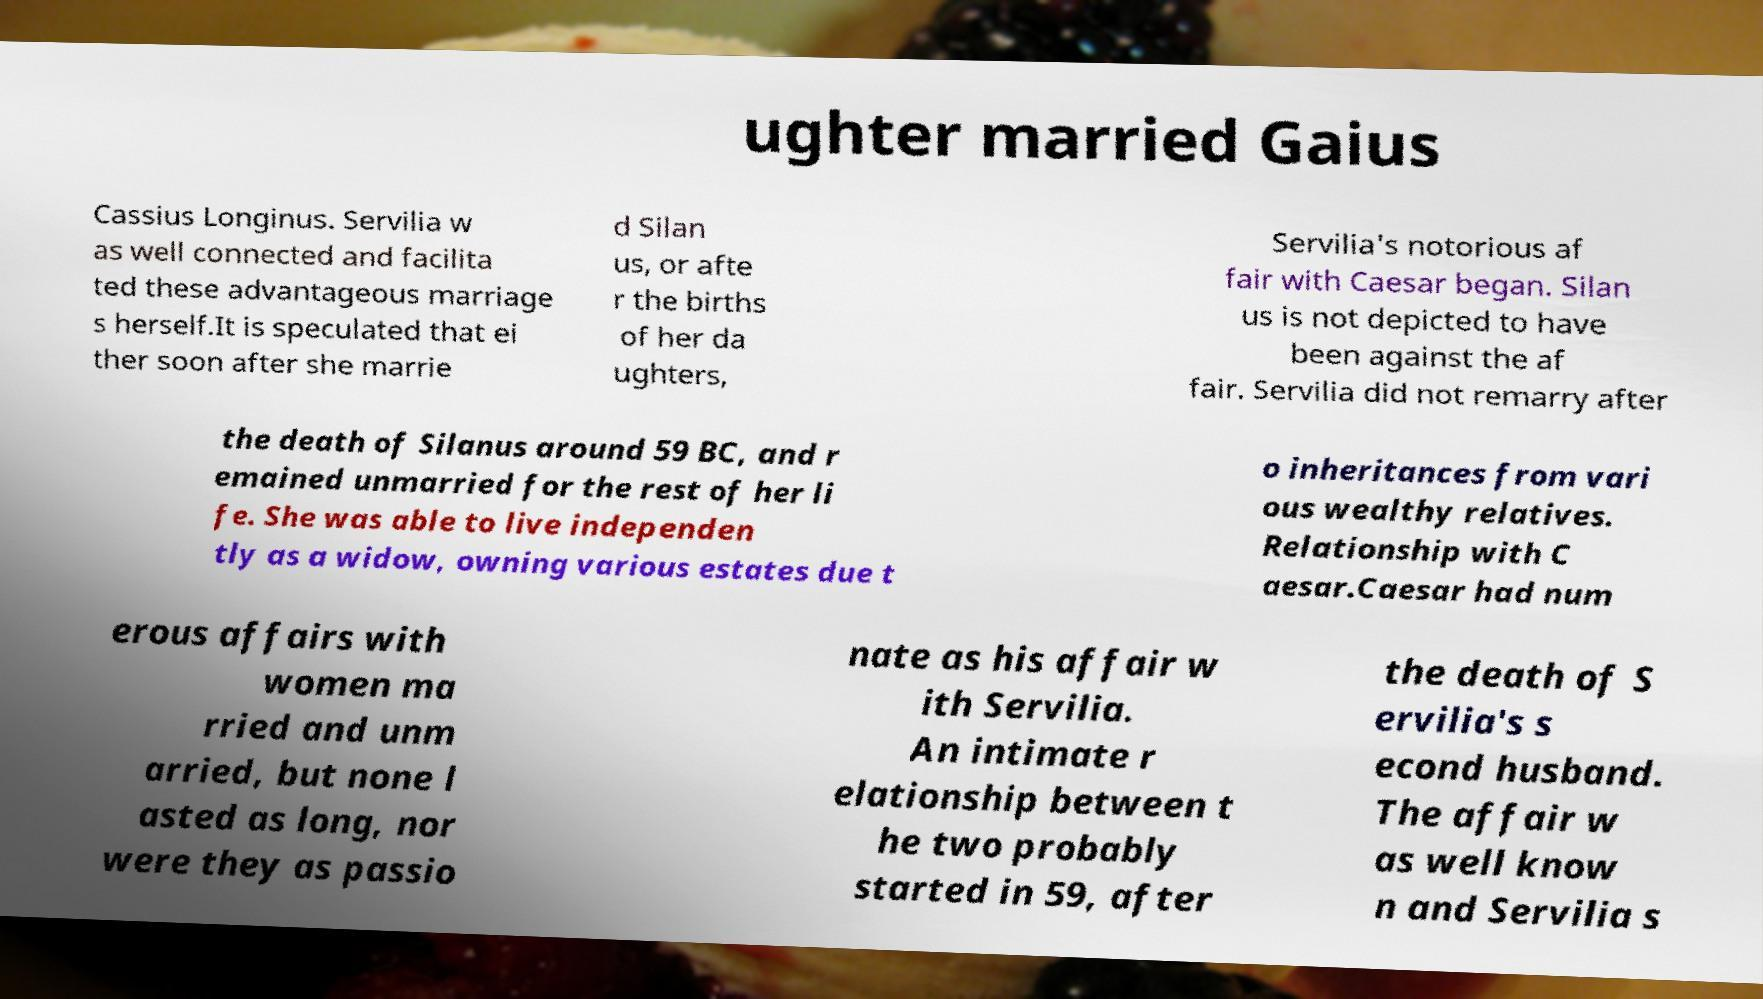Could you extract and type out the text from this image? ughter married Gaius Cassius Longinus. Servilia w as well connected and facilita ted these advantageous marriage s herself.It is speculated that ei ther soon after she marrie d Silan us, or afte r the births of her da ughters, Servilia's notorious af fair with Caesar began. Silan us is not depicted to have been against the af fair. Servilia did not remarry after the death of Silanus around 59 BC, and r emained unmarried for the rest of her li fe. She was able to live independen tly as a widow, owning various estates due t o inheritances from vari ous wealthy relatives. Relationship with C aesar.Caesar had num erous affairs with women ma rried and unm arried, but none l asted as long, nor were they as passio nate as his affair w ith Servilia. An intimate r elationship between t he two probably started in 59, after the death of S ervilia's s econd husband. The affair w as well know n and Servilia s 